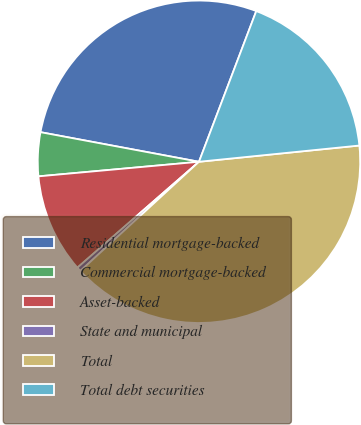Convert chart. <chart><loc_0><loc_0><loc_500><loc_500><pie_chart><fcel>Residential mortgage-backed<fcel>Commercial mortgage-backed<fcel>Asset-backed<fcel>State and municipal<fcel>Total<fcel>Total debt securities<nl><fcel>27.84%<fcel>4.38%<fcel>9.96%<fcel>0.44%<fcel>39.76%<fcel>17.61%<nl></chart> 